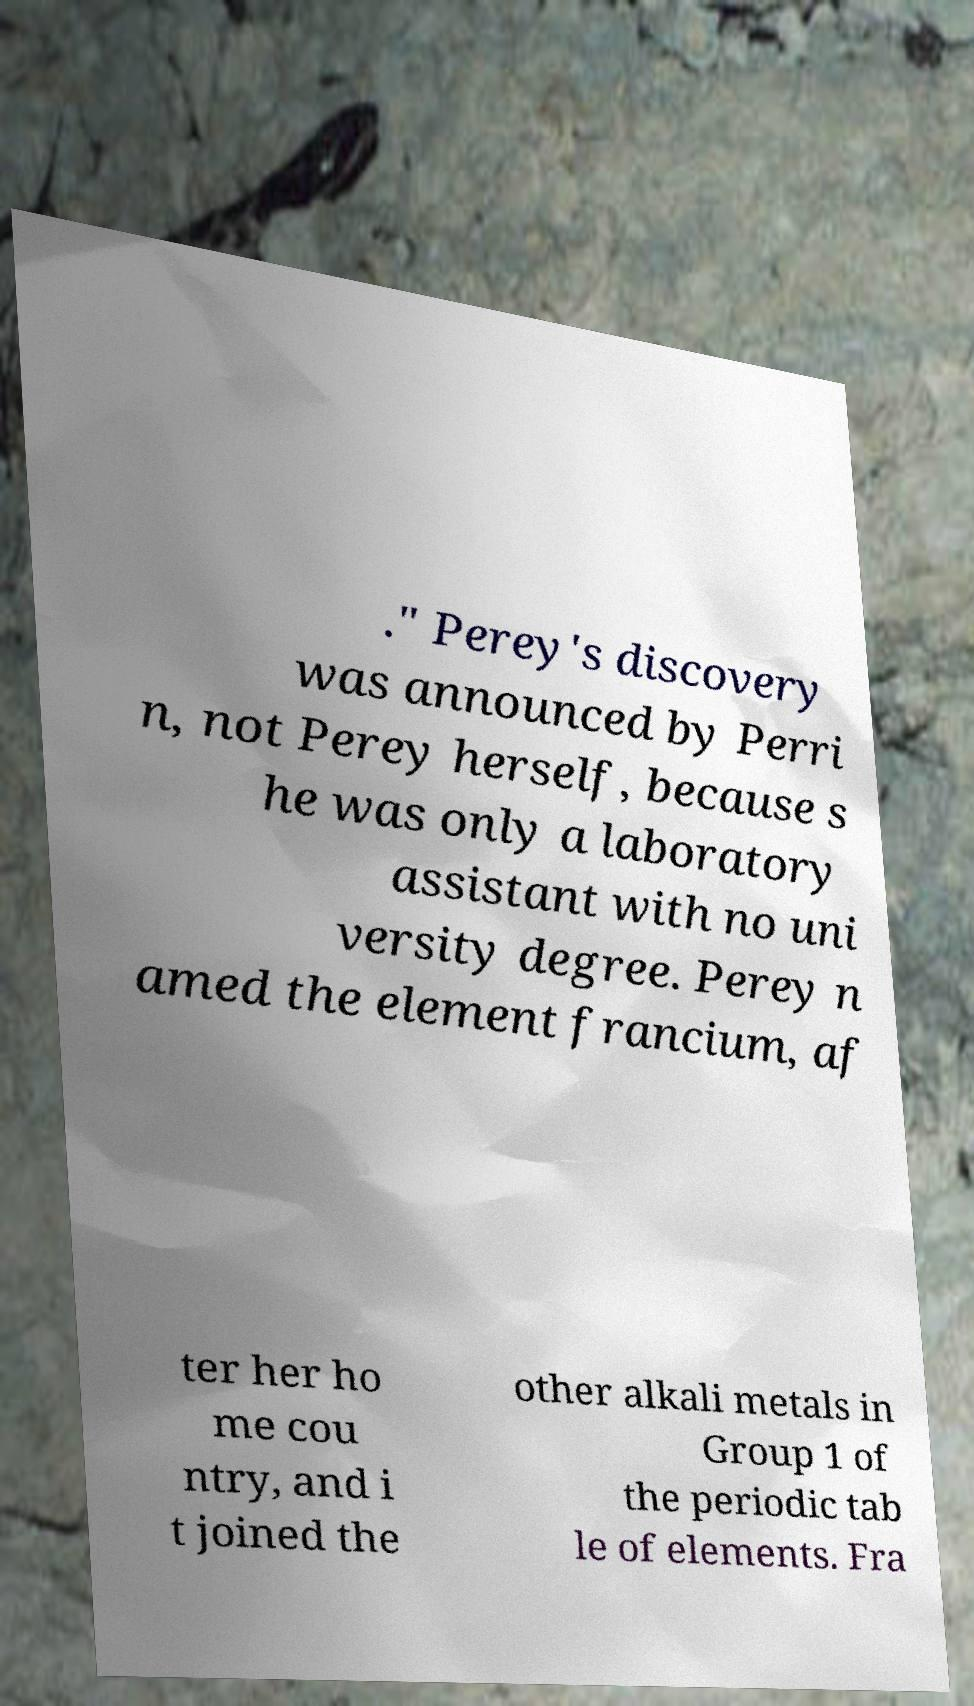What messages or text are displayed in this image? I need them in a readable, typed format. ." Perey's discovery was announced by Perri n, not Perey herself, because s he was only a laboratory assistant with no uni versity degree. Perey n amed the element francium, af ter her ho me cou ntry, and i t joined the other alkali metals in Group 1 of the periodic tab le of elements. Fra 